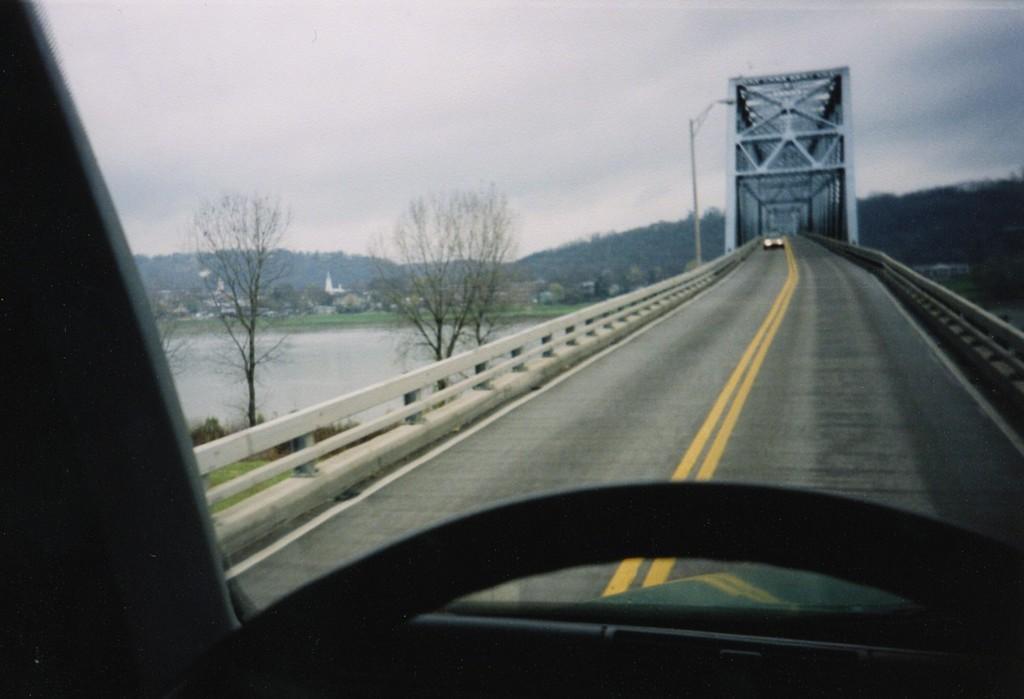Describe this image in one or two sentences. In this image there is a bridge and we can see vehicles on the bridge. On the left there are trees and water. In the background there are hills, pole and sky. 